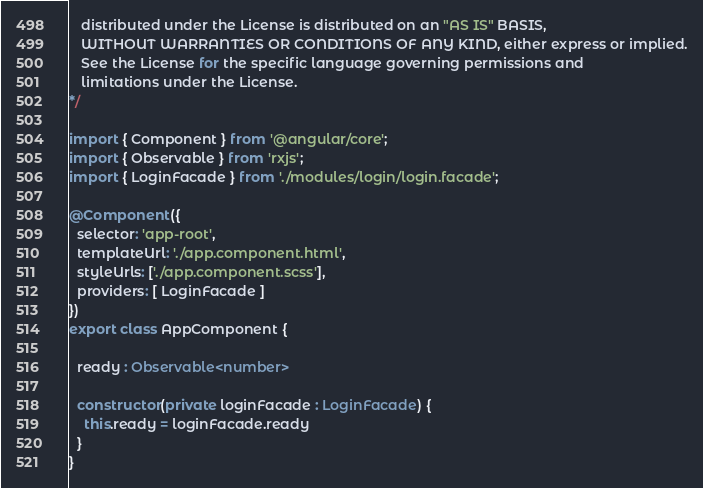Convert code to text. <code><loc_0><loc_0><loc_500><loc_500><_TypeScript_>   distributed under the License is distributed on an "AS IS" BASIS,
   WITHOUT WARRANTIES OR CONDITIONS OF ANY KIND, either express or implied.
   See the License for the specific language governing permissions and
   limitations under the License.
*/

import { Component } from '@angular/core';
import { Observable } from 'rxjs';
import { LoginFacade } from './modules/login/login.facade';

@Component({
  selector: 'app-root',
  templateUrl: './app.component.html',
  styleUrls: ['./app.component.scss'],
  providers: [ LoginFacade ]
})
export class AppComponent {

  ready : Observable<number>

  constructor(private loginFacade : LoginFacade) {
    this.ready = loginFacade.ready
  }
}</code> 